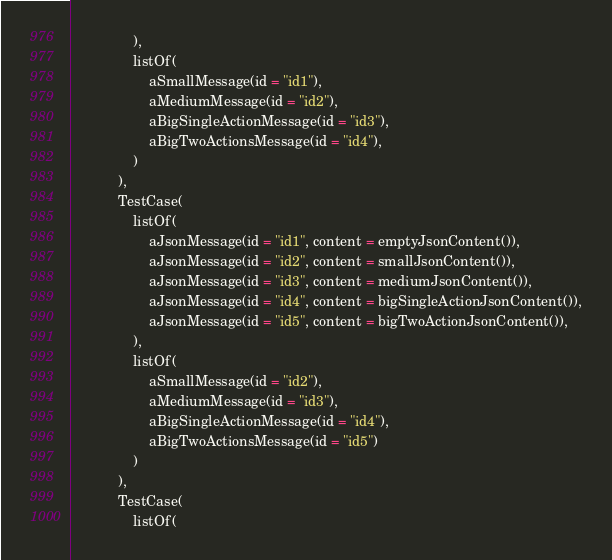<code> <loc_0><loc_0><loc_500><loc_500><_Kotlin_>                ),
                listOf(
                    aSmallMessage(id = "id1"),
                    aMediumMessage(id = "id2"),
                    aBigSingleActionMessage(id = "id3"),
                    aBigTwoActionsMessage(id = "id4"),
                )
            ),
            TestCase(
                listOf(
                    aJsonMessage(id = "id1", content = emptyJsonContent()),
                    aJsonMessage(id = "id2", content = smallJsonContent()),
                    aJsonMessage(id = "id3", content = mediumJsonContent()),
                    aJsonMessage(id = "id4", content = bigSingleActionJsonContent()),
                    aJsonMessage(id = "id5", content = bigTwoActionJsonContent()),
                ),
                listOf(
                    aSmallMessage(id = "id2"),
                    aMediumMessage(id = "id3"),
                    aBigSingleActionMessage(id = "id4"),
                    aBigTwoActionsMessage(id = "id5")
                )
            ),
            TestCase(
                listOf(</code> 